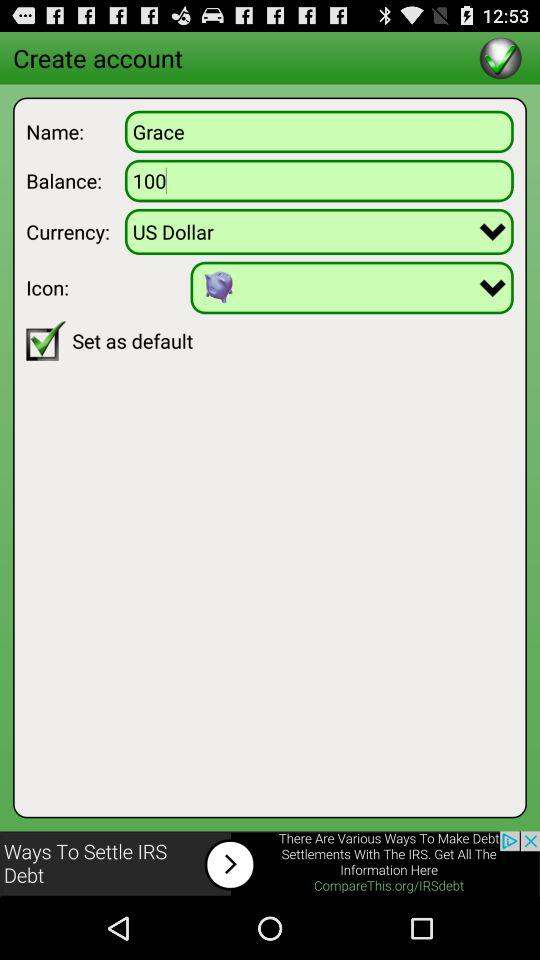What is the name? The name is "Grace". 